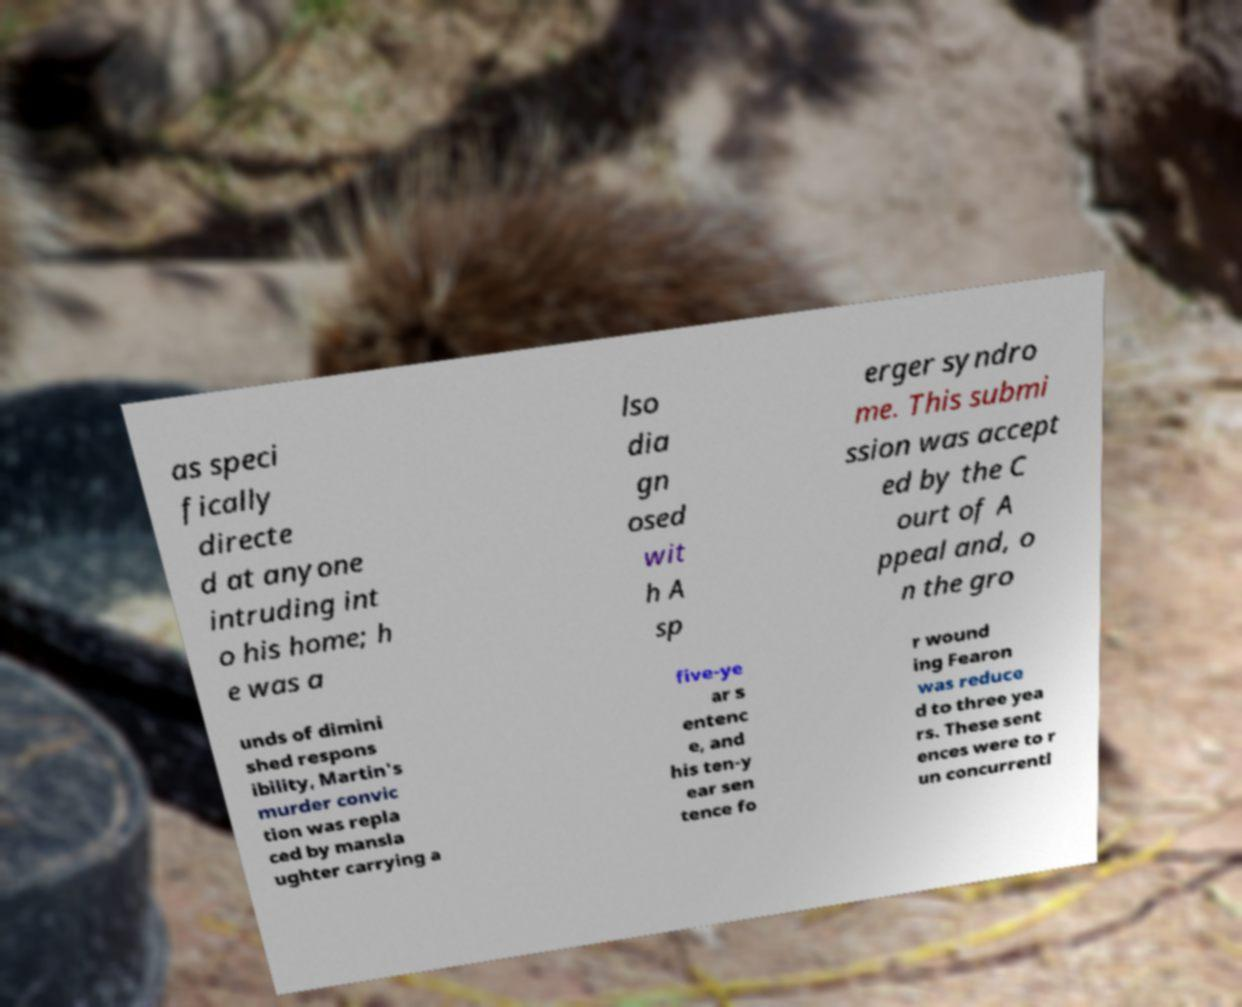I need the written content from this picture converted into text. Can you do that? as speci fically directe d at anyone intruding int o his home; h e was a lso dia gn osed wit h A sp erger syndro me. This submi ssion was accept ed by the C ourt of A ppeal and, o n the gro unds of dimini shed respons ibility, Martin's murder convic tion was repla ced by mansla ughter carrying a five-ye ar s entenc e, and his ten-y ear sen tence fo r wound ing Fearon was reduce d to three yea rs. These sent ences were to r un concurrentl 